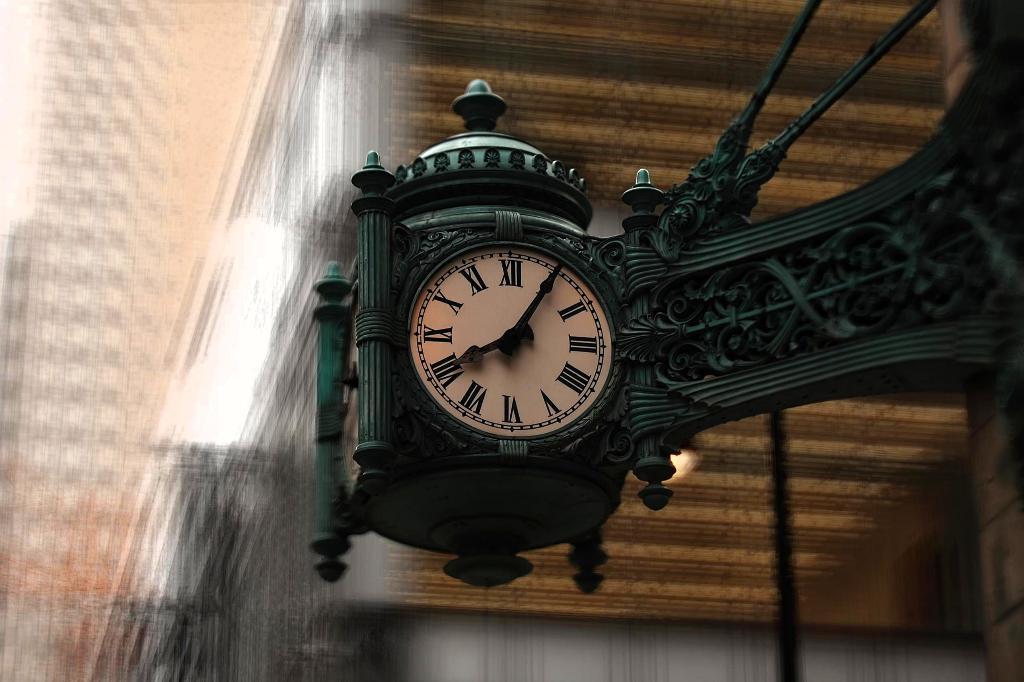Is this clock at 8:05?
Ensure brevity in your answer.  Yes. What time does the clock say?
Your answer should be very brief. 8:05. 